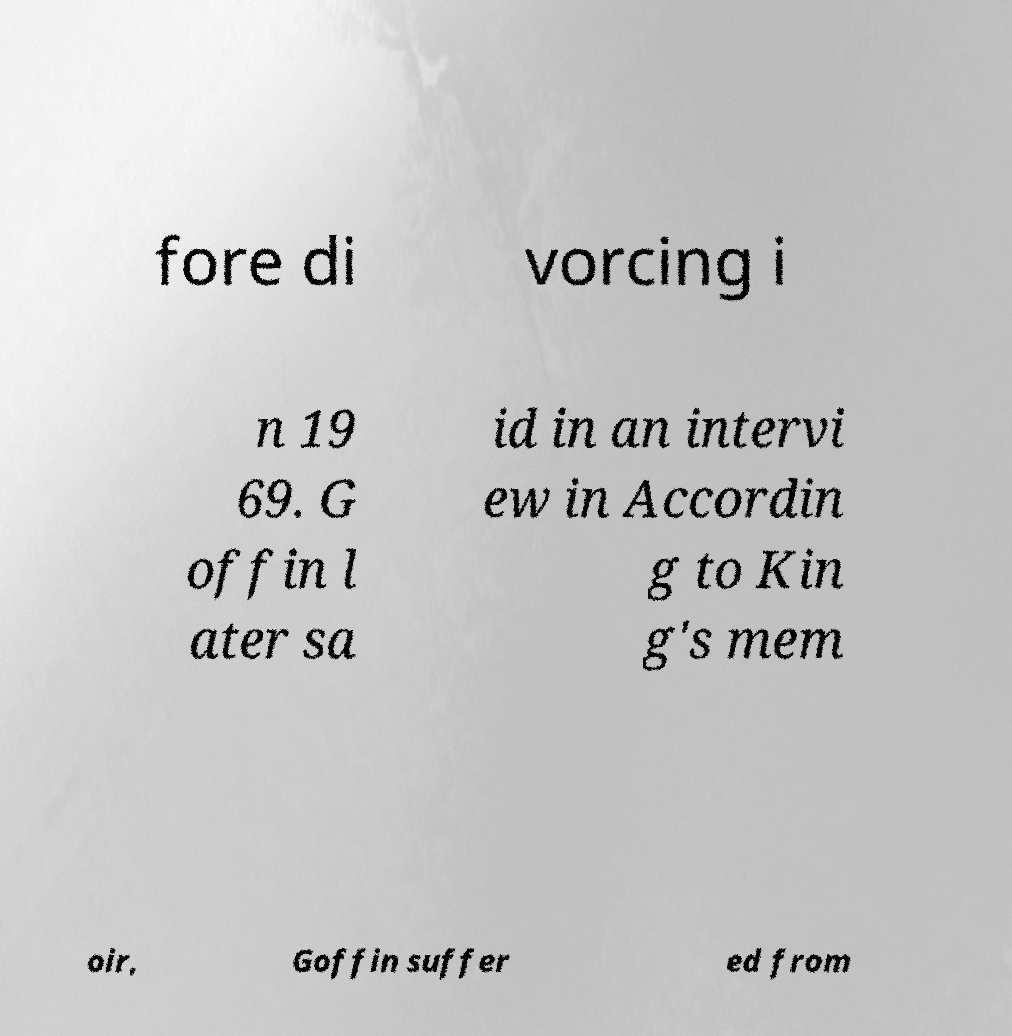Can you read and provide the text displayed in the image?This photo seems to have some interesting text. Can you extract and type it out for me? fore di vorcing i n 19 69. G offin l ater sa id in an intervi ew in Accordin g to Kin g's mem oir, Goffin suffer ed from 